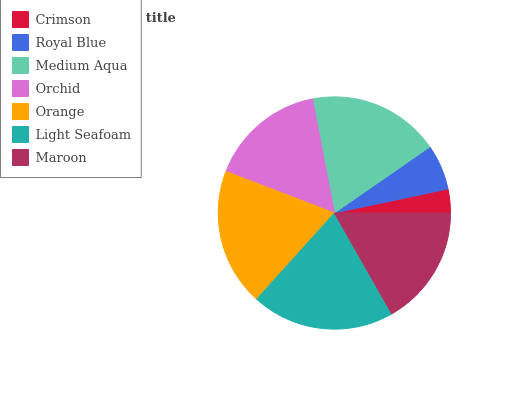Is Crimson the minimum?
Answer yes or no. Yes. Is Light Seafoam the maximum?
Answer yes or no. Yes. Is Royal Blue the minimum?
Answer yes or no. No. Is Royal Blue the maximum?
Answer yes or no. No. Is Royal Blue greater than Crimson?
Answer yes or no. Yes. Is Crimson less than Royal Blue?
Answer yes or no. Yes. Is Crimson greater than Royal Blue?
Answer yes or no. No. Is Royal Blue less than Crimson?
Answer yes or no. No. Is Maroon the high median?
Answer yes or no. Yes. Is Maroon the low median?
Answer yes or no. Yes. Is Orange the high median?
Answer yes or no. No. Is Royal Blue the low median?
Answer yes or no. No. 